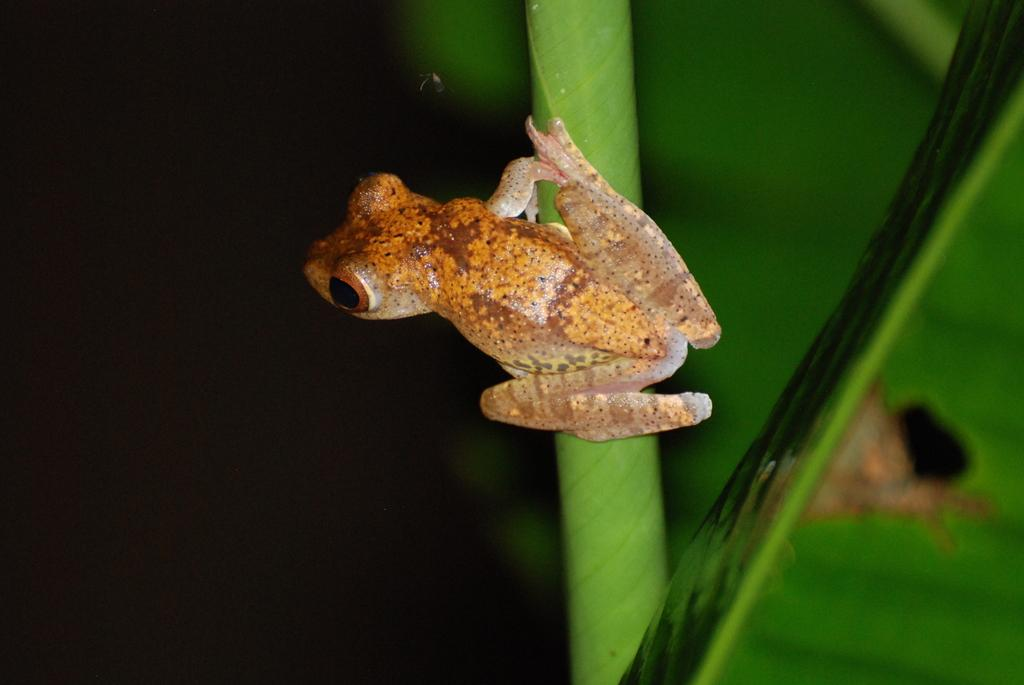What is on the stem in the image? There is a frog on the stem in the image. What can be seen on the right side of the image? There is a leaf on the right side of the image. How would you describe the background of the image? The background of the image has a dark view and a green color. What type of test can be seen in the jar in the image? There is no jar or test present in the image. How does the frog shake the stem in the image? The frog does not shake the stem in the image; it is stationary on the stem. 